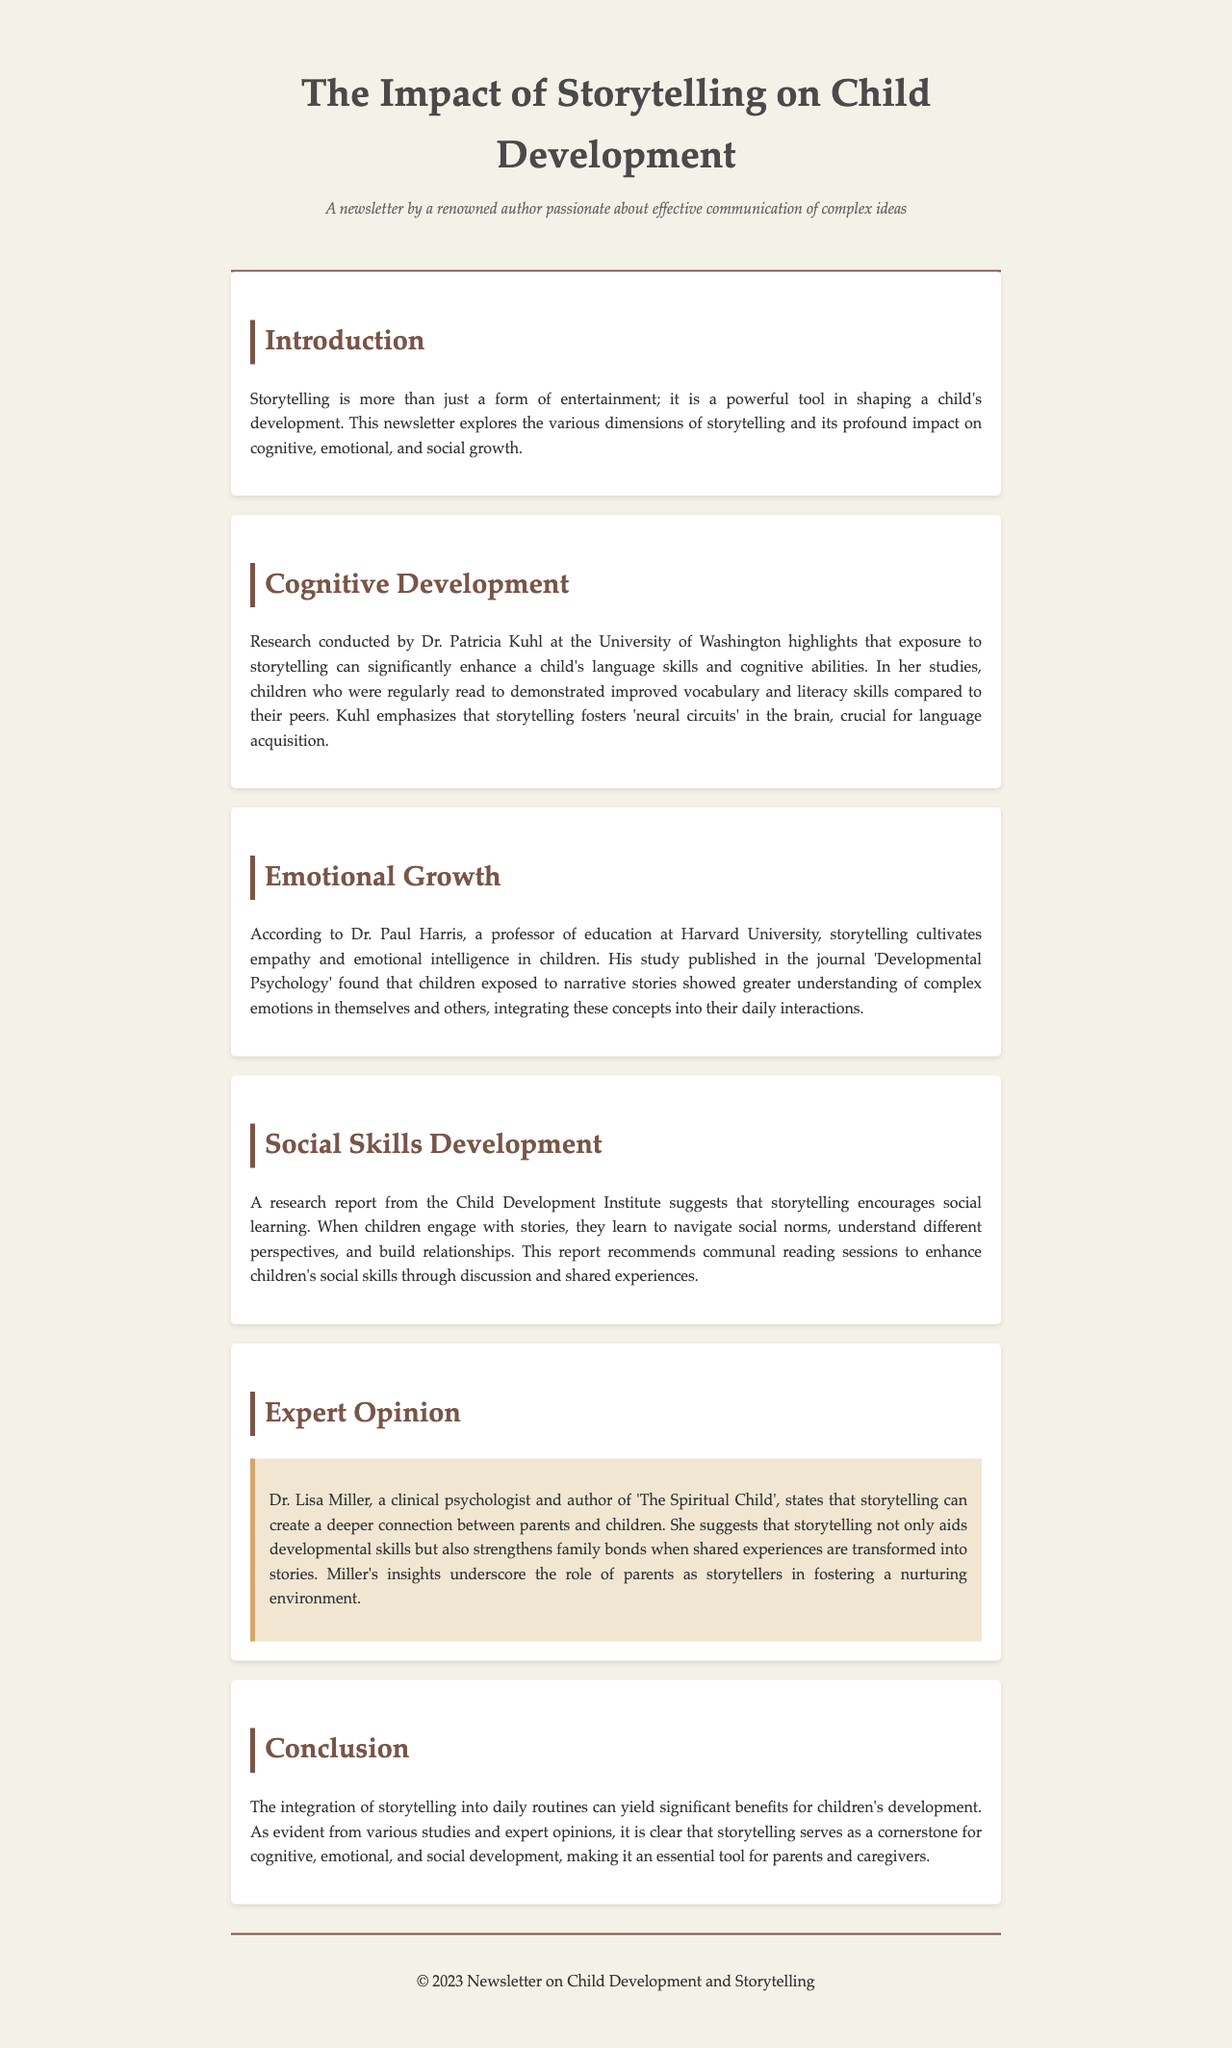What is the main purpose of storytelling? The document explains that storytelling is a powerful tool in shaping a child's development.
Answer: A tool for development Who conducted research on cognitive development related to storytelling? Dr. Patricia Kuhl at the University of Washington conducted research on this topic.
Answer: Dr. Patricia Kuhl What is one emotional benefit of storytelling mentioned in the document? Storytelling cultivates empathy and emotional intelligence in children.
Answer: Empathy According to the Child Development Institute, what do stories encourage in children? The research report suggests that storytelling encourages social learning.
Answer: Social learning What does Dr. Lisa Miller believe storytelling strengthens? Dr. Lisa Miller states that storytelling strengthens family bonds.
Answer: Family bonds In what journal was Dr. Paul Harris's study published? Dr. Paul Harris's study was published in the journal 'Developmental Psychology'.
Answer: 'Developmental Psychology' What is a recommended activity to enhance children's social skills? The document recommends communal reading sessions for enhancing social skills.
Answer: Communal reading sessions How does storytelling affect children's vocabulary? The document notes that children who were regularly read to showed improved vocabulary.
Answer: Improved vocabulary 